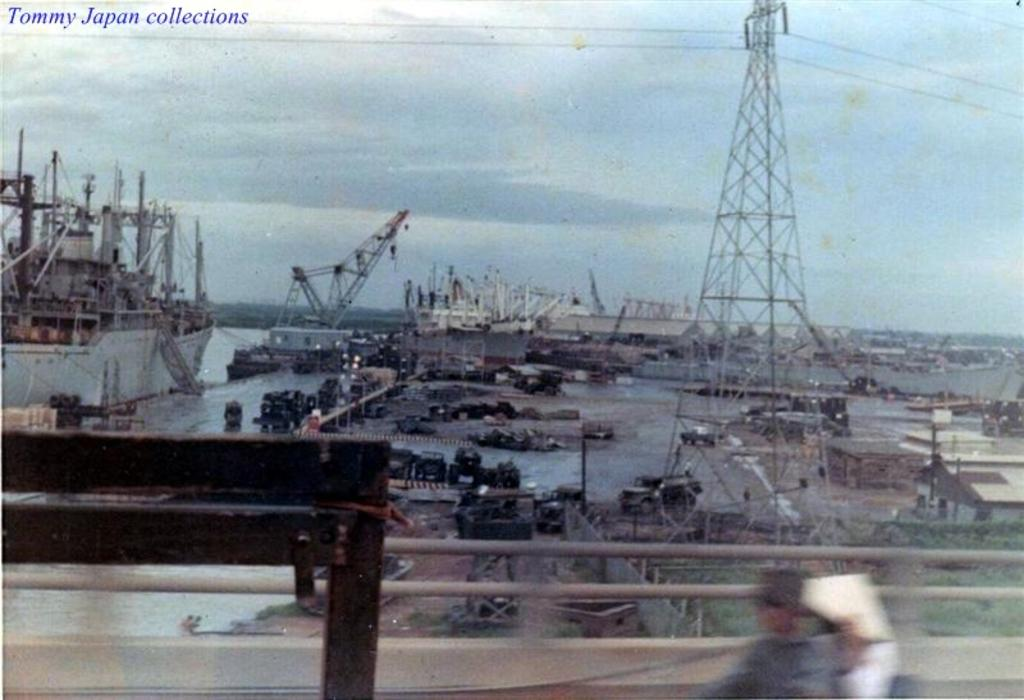What is on the water surface in the image? There are ships on the water surface in the image. Can you describe the people visible in the image? Unfortunately, the facts provided do not give any details about the people in the image. What type of water surface is visible in the image? The facts provided do not specify the type of water surface. What type of tin can be seen in the image? There is no tin present in the image. What scent is associated with the people in the image? There is no information about the scent of the people in the image. 